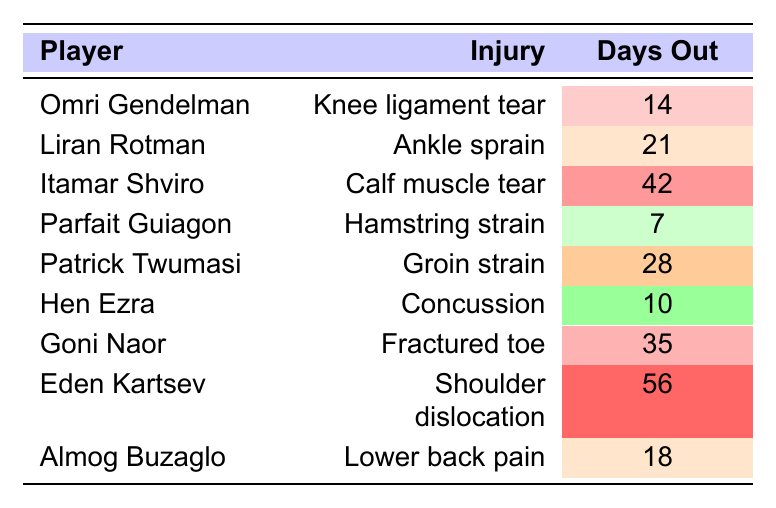What is the longest injury duration reported in the table? The table displays the "Days Out" column with various values for each player. The highest value in this column is 56 days, reported for Eden Kartsev.
Answer: 56 days Which player suffered from a calf muscle tear? Referring to the "Injury" column and matching it with the player's name, Itamar Shviro is identified as the player with a calf muscle tear.
Answer: Itamar Shviro How many players reported injuries that resulted in more than 21 days out? By checking the "Days Out" column, three players reported injuries lasting longer than 21 days: Itamar Shviro (42 days), Patrick Twumasi (28 days), and Eden Kartsev (56 days).
Answer: 3 players Is there any player who has been reported with a groin strain? The "Injury" column shows that Patrick Twumasi has a groin strain. Thus, the answer is yes, there is a player with that injury.
Answer: Yes What is the average number of days out for all the players? To find the average, we sum the "Days Out" values: 14 + 21 + 42 + 7 + 28 + 10 + 35 + 56 + 18 = 231; there are 9 players so, the average is 231/9 = 25.67.
Answer: 25.67 days Who suffered the most severe injury based on days out? Analyzing the "Days Out" column, Eden Kartsev with 56 days out has the most severe injury, followed by Itamar Shviro with 42 days.
Answer: Eden Kartsev What is the difference in days out between the player with the longest injury and the player with the shortest injury duration? The longest injury duration is 56 days (Eden Kartsev) and the shortest is 7 days (Parfait Guiagon). The difference is 56 - 7 = 49 days.
Answer: 49 days How many players had injuries that required them to be out for less than 20 days? Checking the "Days Out" column, Parfait Guiagon (7 days) and Hen Ezra (10 days) had injuries resulting in fewer than 20 days out, giving us a total of 2 players.
Answer: 2 players Which injuries are recorded for players with more than 30 days out? By evaluating the "Injury" column for players with more than 30 days out (Itamar Shviro, Goni Naor, Eden Kartsev), the injuries are: Calf muscle tear, Fractured toe, and Shoulder dislocation.
Answer: Calf muscle tear, Fractured toe, Shoulder dislocation Is Liran Rotman's injury more severe than that of Parfait Guiagon? Liran Rotman has an ankle sprain (21 days out) and Parfait Guiagon has a hamstring strain (7 days out). Since 21 is greater than 7, Liran Rotman's injury is indeed more severe.
Answer: Yes 